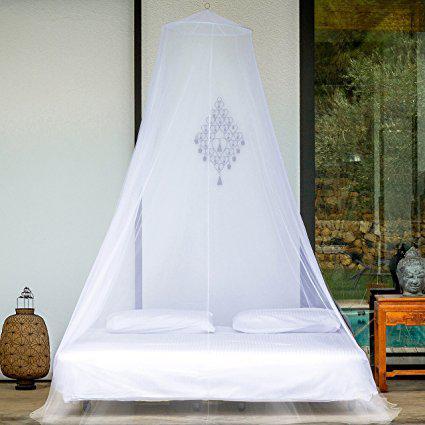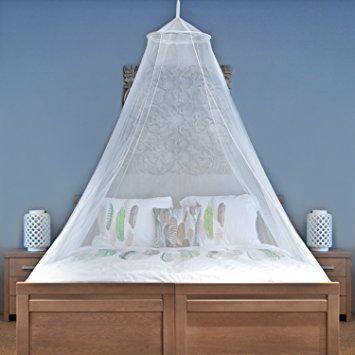The first image is the image on the left, the second image is the image on the right. For the images displayed, is the sentence "There are two circle canopies." factually correct? Answer yes or no. Yes. The first image is the image on the left, the second image is the image on the right. Considering the images on both sides, is "There are two white round canopies." valid? Answer yes or no. Yes. 